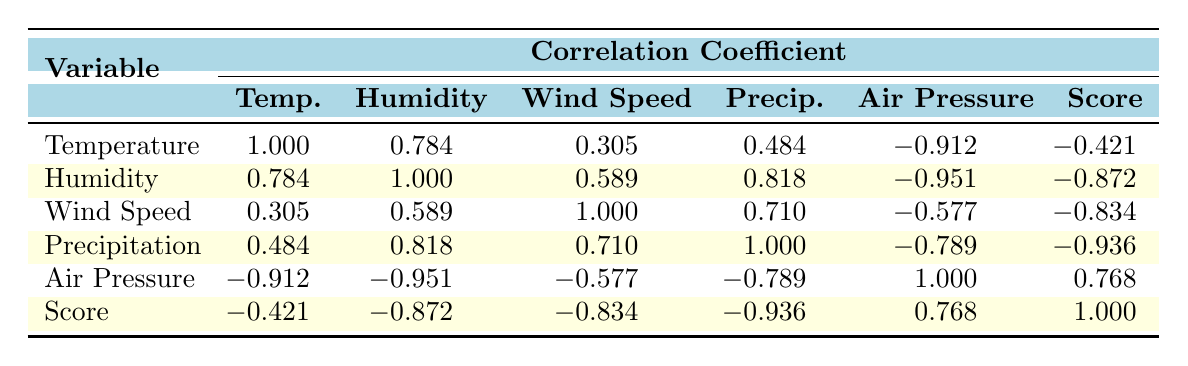What is the correlation coefficient between humidity and competition score? From the table, the correlation coefficient between humidity and competition score is -0.872. This means there is a strong negative correlation, indicating that as humidity increases, competition scores tend to decrease.
Answer: -0.872 What is the highest correlation coefficient value found with the air pressure? The highest correlation coefficient with air pressure is 0.768, which is with competition score. This shows a positive relationship, meaning that as air pressure increases, competition scores tend to increase as well.
Answer: 0.768 Which variable has the strongest negative correlation with competition score? The variable with the strongest negative correlation with competition score is precipitation, with a correlation coefficient of -0.936. This indicates that higher precipitation is associated with lower competition scores.
Answer: -0.936 What is the difference between the correlation coefficients of temperature and wind speed? The correlation coefficient for temperature is -0.421 and for wind speed it is -0.834. The difference is calculated as -0.421 - (-0.834) = 0.413, showing that the negative correlation with wind speed is stronger.
Answer: 0.413 Is there a positive correlation between temperature and air pressure? Yes, the correlation coefficient for temperature and air pressure is -0.912, indicating a strong negative correlation; therefore, this question is false. Higher temperatures are associated with lower air pressure.
Answer: No What is the average correlation coefficient value for humidity and precipitation with competition score? The correlation coefficients for humidity and precipitation with competition score are -0.872 and -0.936 respectively. The average is calculated as (-0.872 + -0.936) / 2 = -0.904.
Answer: -0.904 How does the correlation between wind speed and competition score compare to that of air pressure and competition score? The correlation coefficient for wind speed with competition score is -0.834, while for air pressure it is 0.768. The wind speed has a stronger negative correlation, suggesting that increases in wind speed are more negatively impacting competition scores than the positive impact of air pressure.
Answer: Stronger negative for wind speed What is the median correlation coefficient among the variables listed? The correlation coefficients are as follows: 1.000, 0.784, 0.305, 0.484, -0.912, -0.421, 1.000, -0.872, -0.834, -0.936, 0.768. After sorting these values, the median is calculated as the average of the 5th and 6th values (which are -0.421 and 0.768), resulting in -0.421 + 0.768 = 0.347 / 2 = 0.173.
Answer: 0.173 What is the correlation value between wind speed and precipitation? The correlation coefficient value between wind speed and precipitation is 0.710, indicating a positive relationship; as wind speed increases, precipitation also tends to increase.
Answer: 0.710 